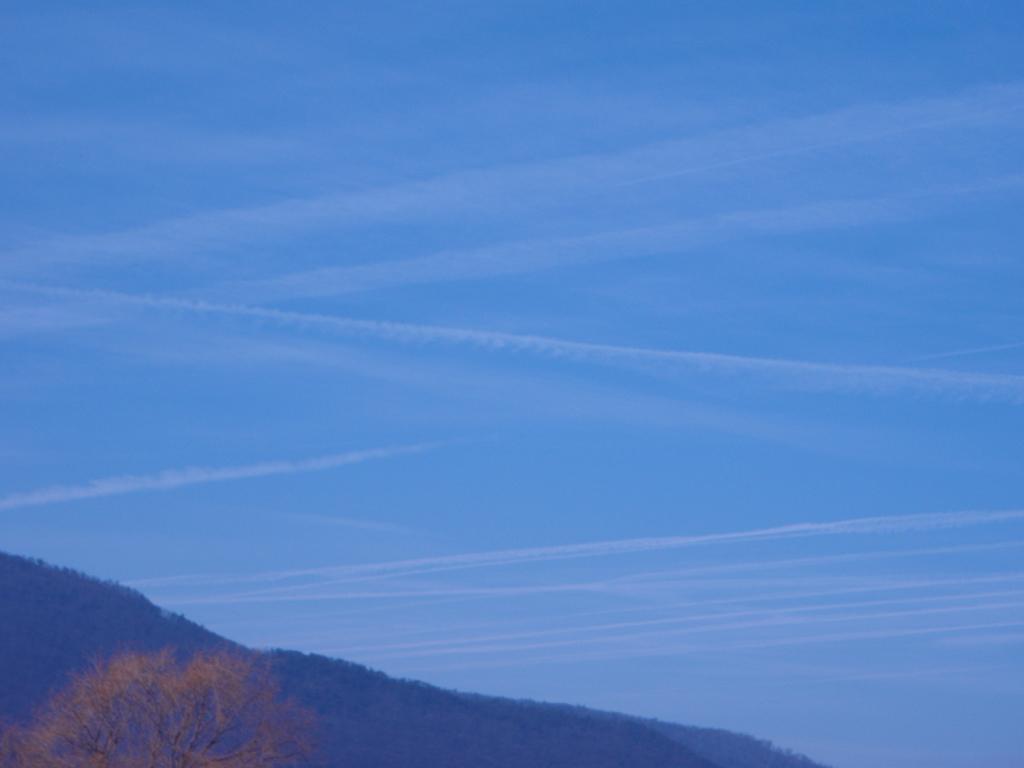Describe this image in one or two sentences. Here we can see a tree and a mountain. In the background there is sky. 